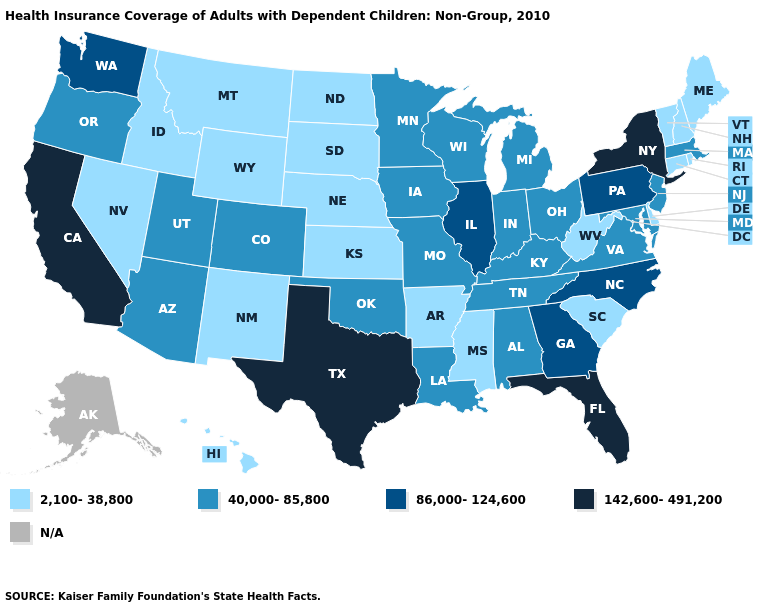Does Wyoming have the lowest value in the West?
Write a very short answer. Yes. Does New Jersey have the lowest value in the USA?
Short answer required. No. Does Montana have the highest value in the West?
Write a very short answer. No. Does Utah have the lowest value in the West?
Concise answer only. No. What is the value of South Dakota?
Quick response, please. 2,100-38,800. Among the states that border Indiana , which have the lowest value?
Short answer required. Kentucky, Michigan, Ohio. What is the value of New Hampshire?
Quick response, please. 2,100-38,800. What is the value of Delaware?
Concise answer only. 2,100-38,800. What is the lowest value in states that border Missouri?
Write a very short answer. 2,100-38,800. Does Texas have the highest value in the USA?
Write a very short answer. Yes. What is the value of Oklahoma?
Be succinct. 40,000-85,800. What is the highest value in the USA?
Write a very short answer. 142,600-491,200. What is the value of South Dakota?
Quick response, please. 2,100-38,800. Which states have the lowest value in the MidWest?
Be succinct. Kansas, Nebraska, North Dakota, South Dakota. 